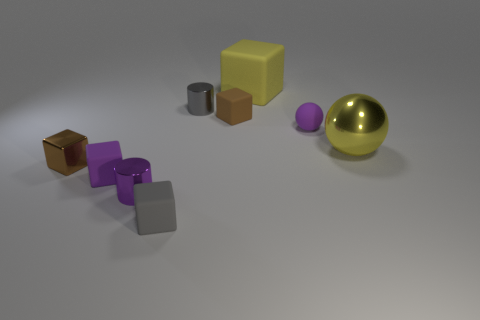How many other things are made of the same material as the yellow cube?
Offer a terse response. 4. There is a tiny matte block behind the small brown shiny thing; does it have the same color as the big matte cube?
Your answer should be compact. No. What number of metal objects are either tiny purple cylinders or yellow blocks?
Offer a terse response. 1. Is there anything else that has the same size as the purple matte cube?
Make the answer very short. Yes. The big thing that is made of the same material as the purple sphere is what color?
Make the answer very short. Yellow. What number of blocks are either purple things or brown metal objects?
Provide a succinct answer. 2. What number of things are either rubber cylinders or cylinders on the right side of the tiny gray block?
Your answer should be compact. 1. Are any gray rubber cubes visible?
Your response must be concise. Yes. What number of shiny spheres are the same color as the shiny cube?
Make the answer very short. 0. There is another cube that is the same color as the shiny cube; what material is it?
Your answer should be compact. Rubber. 